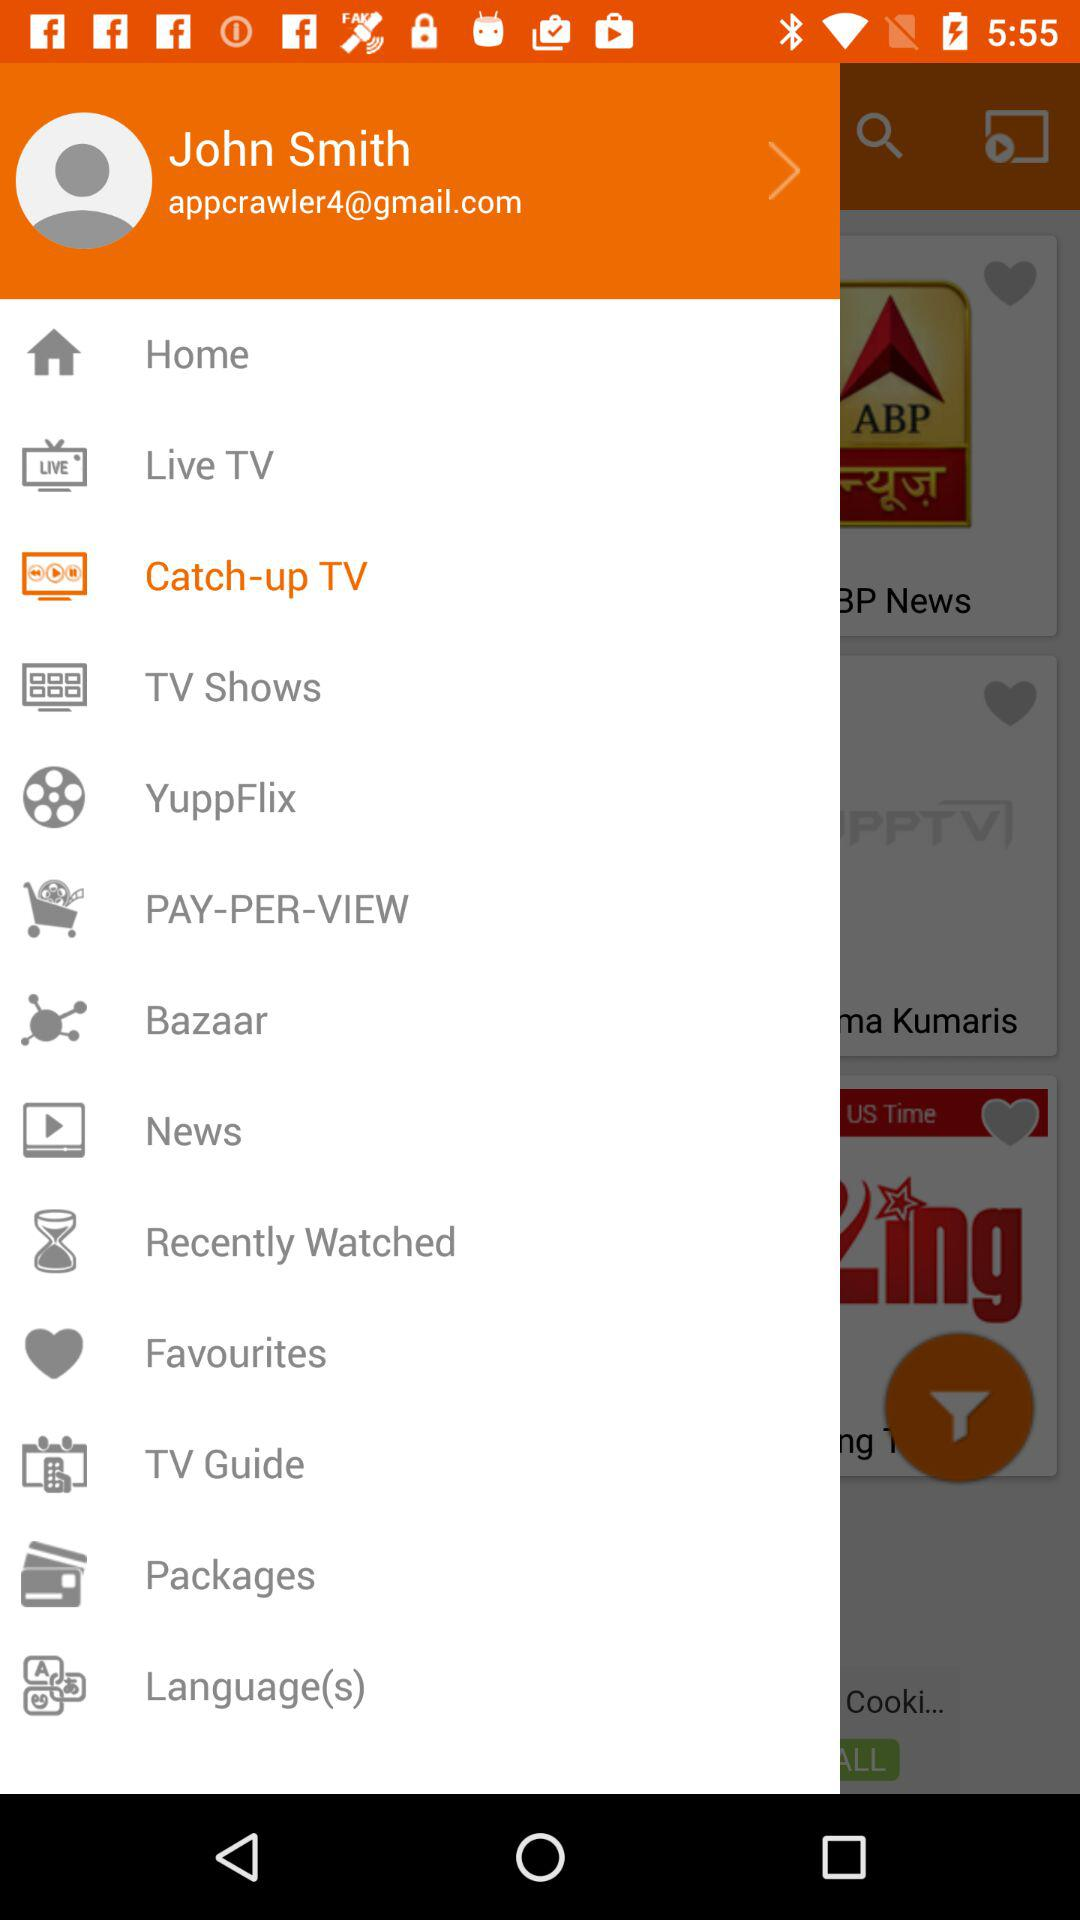What is the user name? The user name is John Smith. 